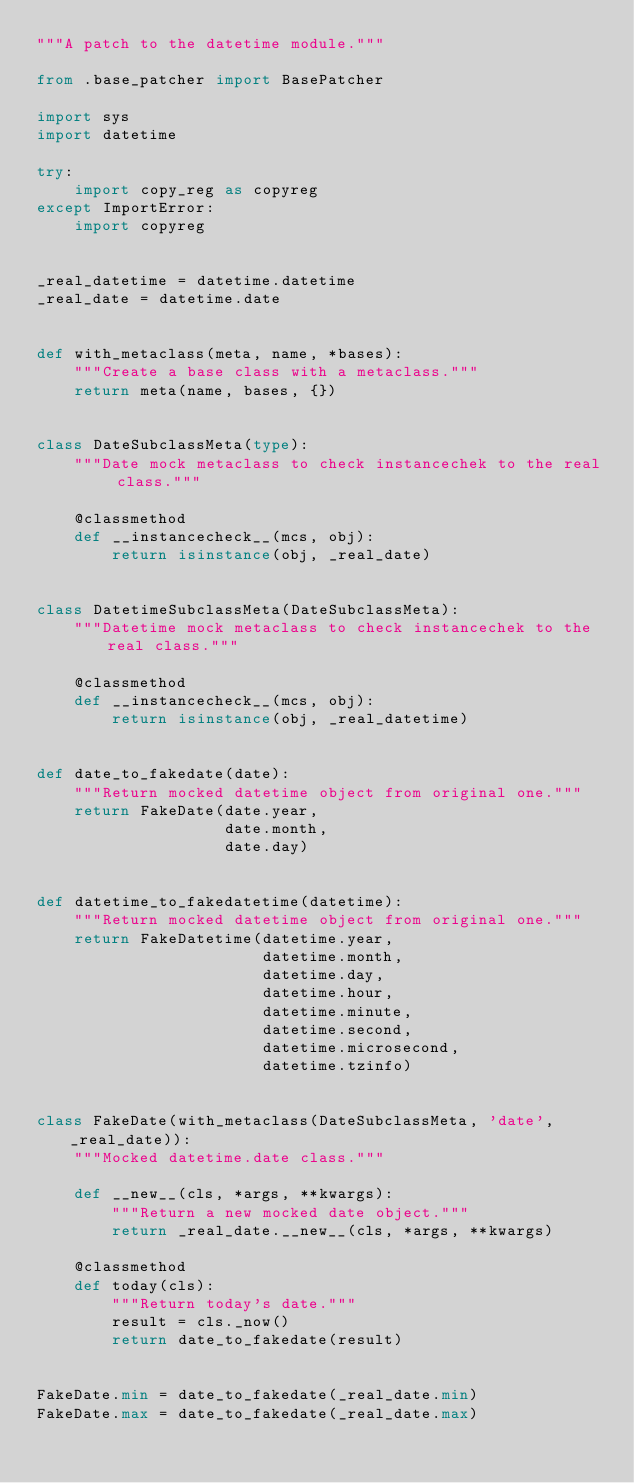<code> <loc_0><loc_0><loc_500><loc_500><_Python_>"""A patch to the datetime module."""

from .base_patcher import BasePatcher

import sys
import datetime

try:
    import copy_reg as copyreg
except ImportError:
    import copyreg


_real_datetime = datetime.datetime
_real_date = datetime.date


def with_metaclass(meta, name, *bases):
    """Create a base class with a metaclass."""
    return meta(name, bases, {})


class DateSubclassMeta(type):
    """Date mock metaclass to check instancechek to the real class."""

    @classmethod
    def __instancecheck__(mcs, obj):
        return isinstance(obj, _real_date)


class DatetimeSubclassMeta(DateSubclassMeta):
    """Datetime mock metaclass to check instancechek to the real class."""

    @classmethod
    def __instancecheck__(mcs, obj):
        return isinstance(obj, _real_datetime)


def date_to_fakedate(date):
    """Return mocked datetime object from original one."""
    return FakeDate(date.year,
                    date.month,
                    date.day)


def datetime_to_fakedatetime(datetime):
    """Return mocked datetime object from original one."""
    return FakeDatetime(datetime.year,
                        datetime.month,
                        datetime.day,
                        datetime.hour,
                        datetime.minute,
                        datetime.second,
                        datetime.microsecond,
                        datetime.tzinfo)


class FakeDate(with_metaclass(DateSubclassMeta, 'date', _real_date)):
    """Mocked datetime.date class."""

    def __new__(cls, *args, **kwargs):
        """Return a new mocked date object."""
        return _real_date.__new__(cls, *args, **kwargs)

    @classmethod
    def today(cls):
        """Return today's date."""
        result = cls._now()
        return date_to_fakedate(result)


FakeDate.min = date_to_fakedate(_real_date.min)
FakeDate.max = date_to_fakedate(_real_date.max)

</code> 